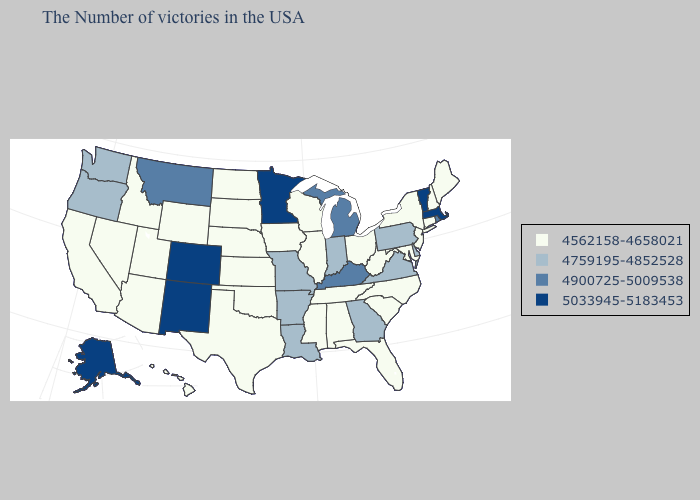Does Mississippi have the lowest value in the South?
Keep it brief. Yes. What is the value of Georgia?
Answer briefly. 4759195-4852528. Name the states that have a value in the range 5033945-5183453?
Short answer required. Massachusetts, Vermont, Minnesota, Colorado, New Mexico, Alaska. Name the states that have a value in the range 5033945-5183453?
Write a very short answer. Massachusetts, Vermont, Minnesota, Colorado, New Mexico, Alaska. Name the states that have a value in the range 4759195-4852528?
Answer briefly. Delaware, Pennsylvania, Virginia, Georgia, Indiana, Louisiana, Missouri, Arkansas, Washington, Oregon. Does New York have the highest value in the Northeast?
Answer briefly. No. What is the value of Wyoming?
Give a very brief answer. 4562158-4658021. How many symbols are there in the legend?
Concise answer only. 4. Name the states that have a value in the range 4562158-4658021?
Give a very brief answer. Maine, New Hampshire, Connecticut, New York, New Jersey, Maryland, North Carolina, South Carolina, West Virginia, Ohio, Florida, Alabama, Tennessee, Wisconsin, Illinois, Mississippi, Iowa, Kansas, Nebraska, Oklahoma, Texas, South Dakota, North Dakota, Wyoming, Utah, Arizona, Idaho, Nevada, California, Hawaii. Name the states that have a value in the range 4900725-5009538?
Concise answer only. Rhode Island, Michigan, Kentucky, Montana. Name the states that have a value in the range 5033945-5183453?
Answer briefly. Massachusetts, Vermont, Minnesota, Colorado, New Mexico, Alaska. Is the legend a continuous bar?
Be succinct. No. Name the states that have a value in the range 4562158-4658021?
Quick response, please. Maine, New Hampshire, Connecticut, New York, New Jersey, Maryland, North Carolina, South Carolina, West Virginia, Ohio, Florida, Alabama, Tennessee, Wisconsin, Illinois, Mississippi, Iowa, Kansas, Nebraska, Oklahoma, Texas, South Dakota, North Dakota, Wyoming, Utah, Arizona, Idaho, Nevada, California, Hawaii. What is the lowest value in the USA?
Short answer required. 4562158-4658021. 